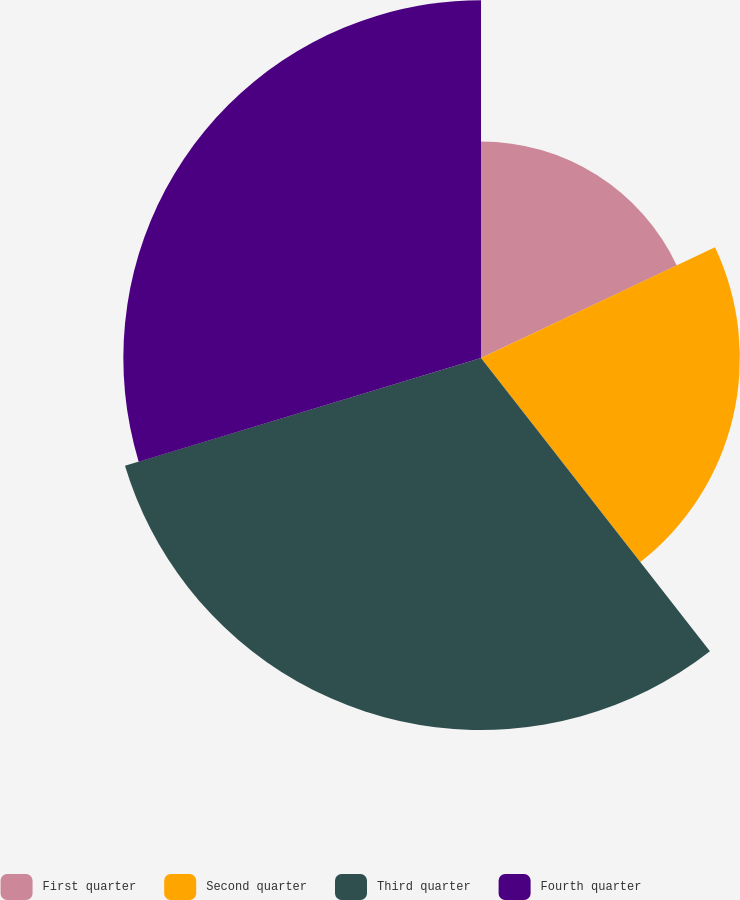Convert chart. <chart><loc_0><loc_0><loc_500><loc_500><pie_chart><fcel>First quarter<fcel>Second quarter<fcel>Third quarter<fcel>Fourth quarter<nl><fcel>17.97%<fcel>21.48%<fcel>30.87%<fcel>29.68%<nl></chart> 